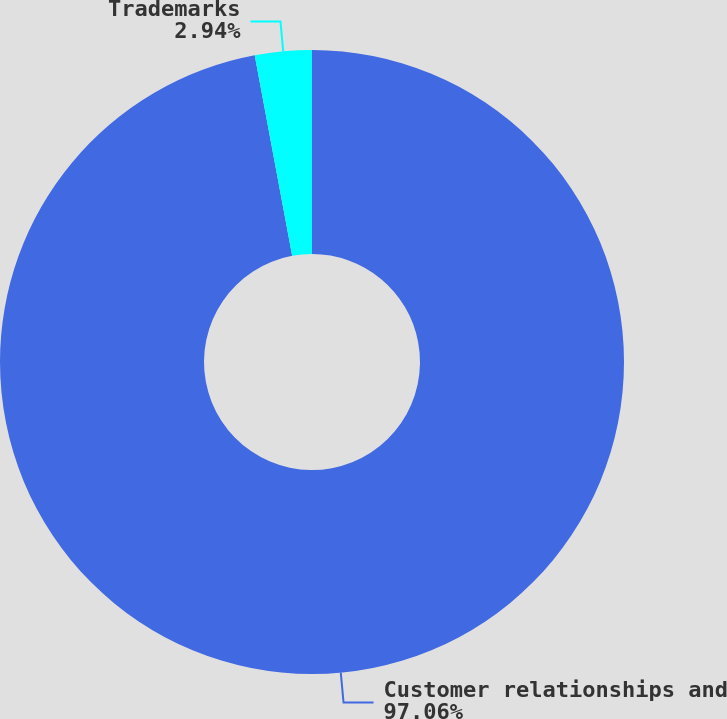Convert chart to OTSL. <chart><loc_0><loc_0><loc_500><loc_500><pie_chart><fcel>Customer relationships and<fcel>Trademarks<nl><fcel>97.06%<fcel>2.94%<nl></chart> 